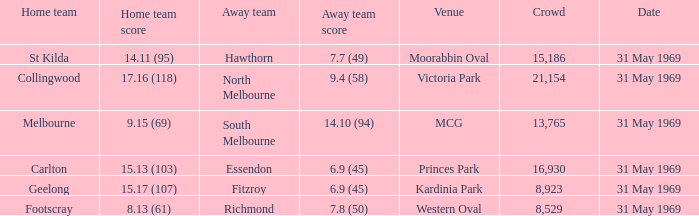Give me the full table as a dictionary. {'header': ['Home team', 'Home team score', 'Away team', 'Away team score', 'Venue', 'Crowd', 'Date'], 'rows': [['St Kilda', '14.11 (95)', 'Hawthorn', '7.7 (49)', 'Moorabbin Oval', '15,186', '31 May 1969'], ['Collingwood', '17.16 (118)', 'North Melbourne', '9.4 (58)', 'Victoria Park', '21,154', '31 May 1969'], ['Melbourne', '9.15 (69)', 'South Melbourne', '14.10 (94)', 'MCG', '13,765', '31 May 1969'], ['Carlton', '15.13 (103)', 'Essendon', '6.9 (45)', 'Princes Park', '16,930', '31 May 1969'], ['Geelong', '15.17 (107)', 'Fitzroy', '6.9 (45)', 'Kardinia Park', '8,923', '31 May 1969'], ['Footscray', '8.13 (61)', 'Richmond', '7.8 (50)', 'Western Oval', '8,529', '31 May 1969']]} Who was the home team that played in Victoria Park? Collingwood. 